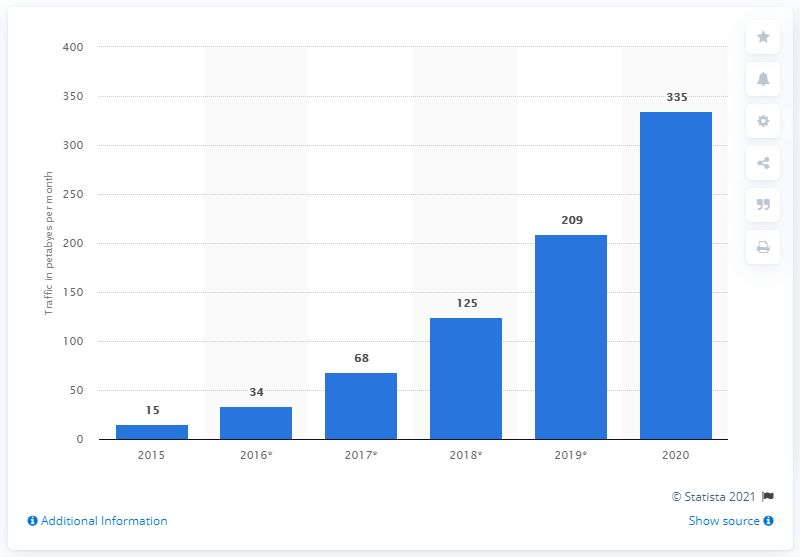Specify some key components in this picture. In 2015, the global wearable device data traffic reached its peak. 